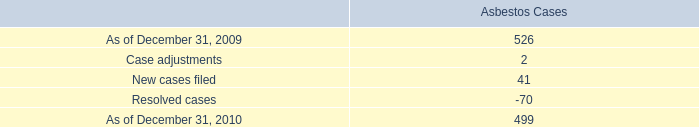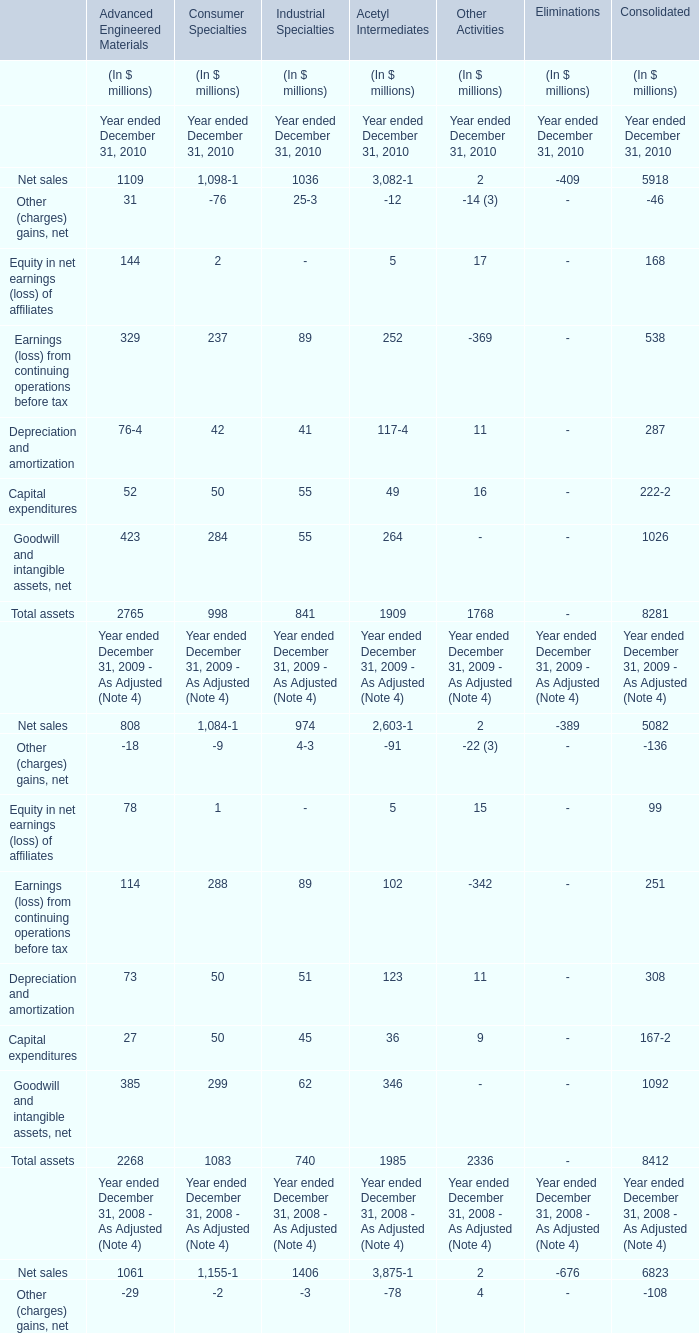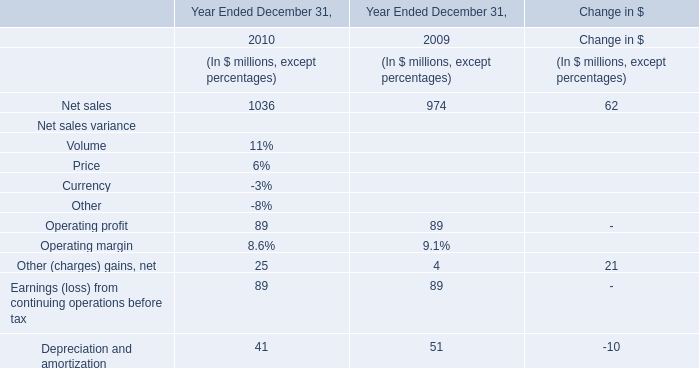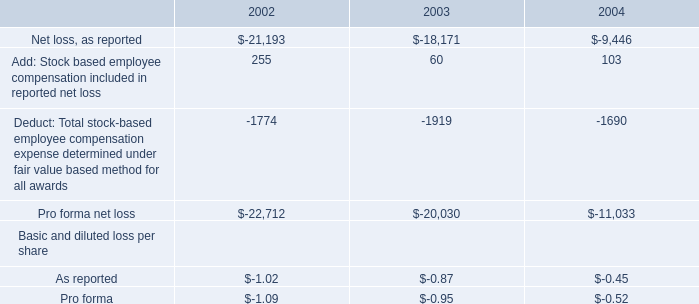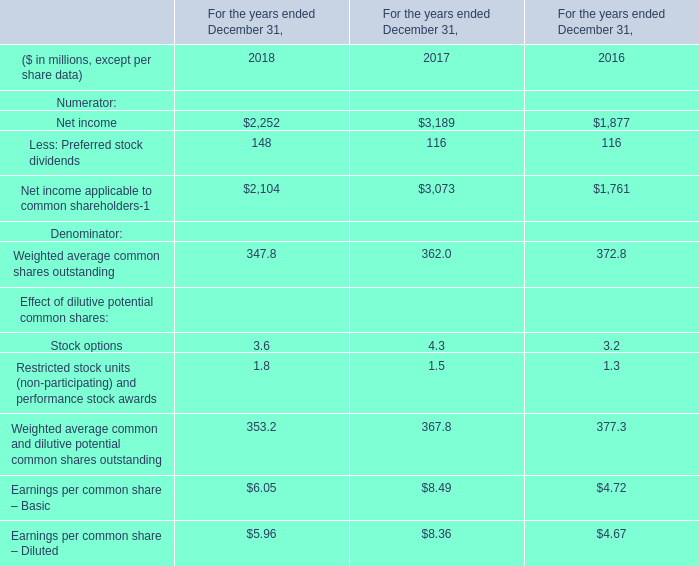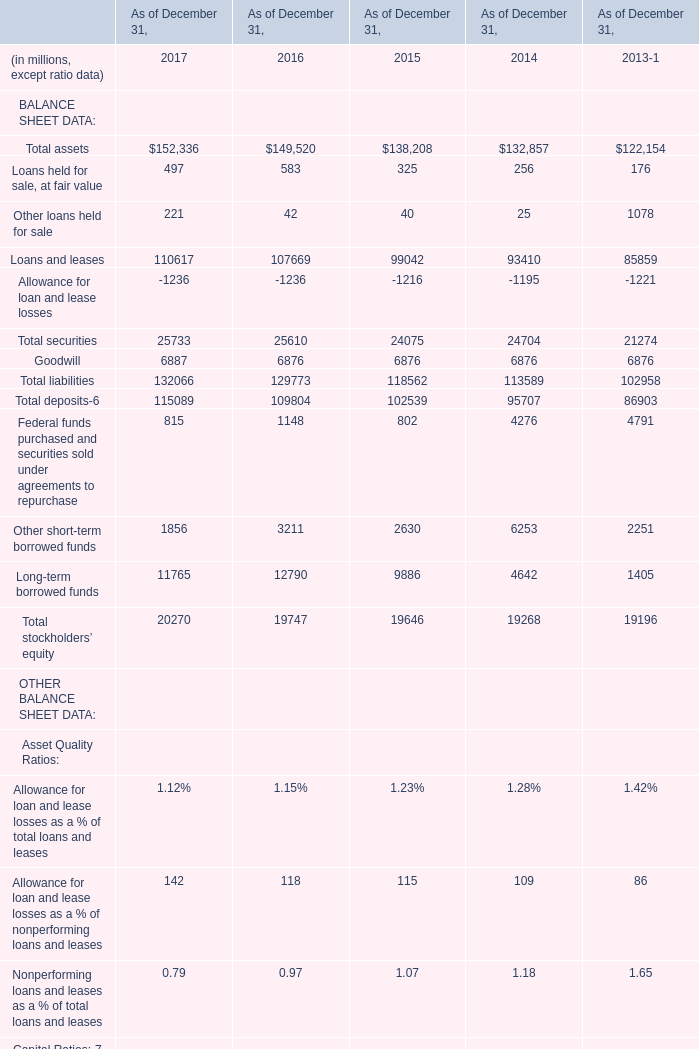What's the average of Net income of For the years ended December 31, 2017, and Loans and leases of As of December 31, 2016 ? 
Computations: ((3189.0 + 107669.0) / 2)
Answer: 55429.0. 